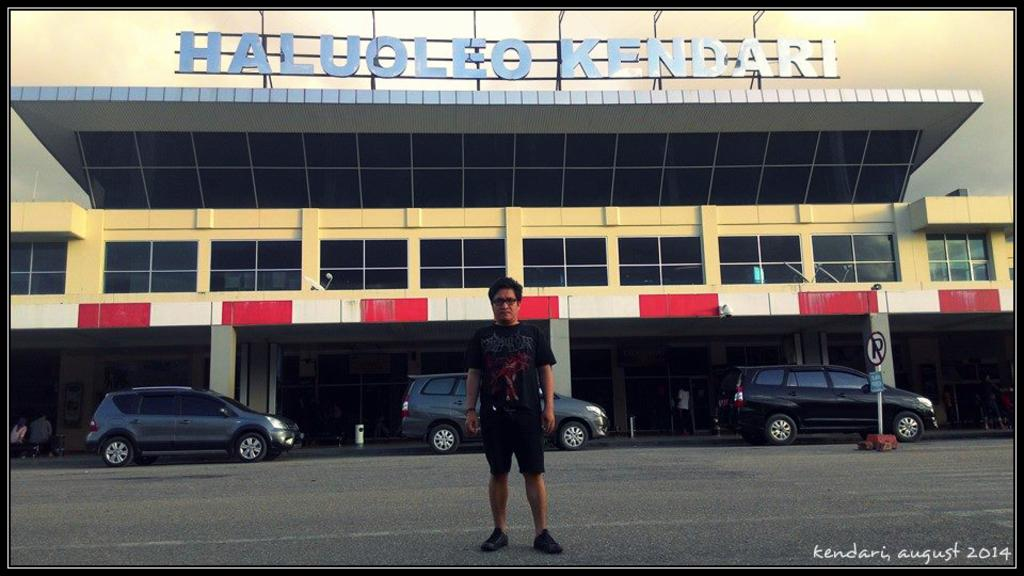What type of structure is visible in the image? There is a building in the image. What architectural features can be seen on the building? There are pillars in the image. Is there any text or information displayed in the image? Yes, there is a signboard in the image. What other object can be seen near the building? There is a pole in the image. What else is present in the image besides the building and its surroundings? There are vehicles and people in the image. What type of business is being conducted in the carriage in the image? There is no carriage present in the image; it features a building, pillars, a signboard, a pole, vehicles, and people. Can you describe the chair that the person is sitting on in the image? There is no chair visible in the image. 